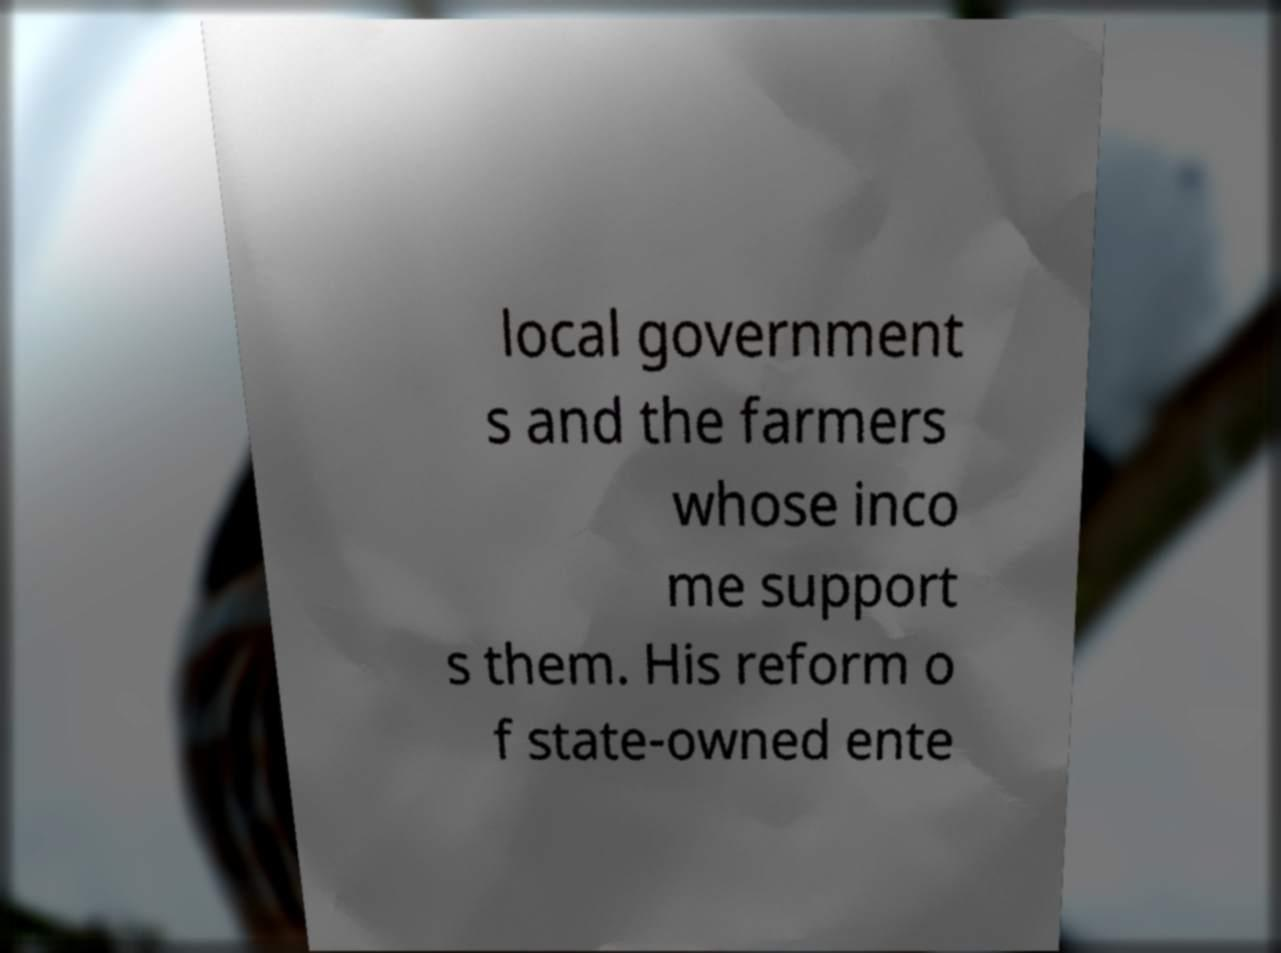Can you accurately transcribe the text from the provided image for me? local government s and the farmers whose inco me support s them. His reform o f state-owned ente 